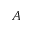Convert formula to latex. <formula><loc_0><loc_0><loc_500><loc_500>A</formula> 